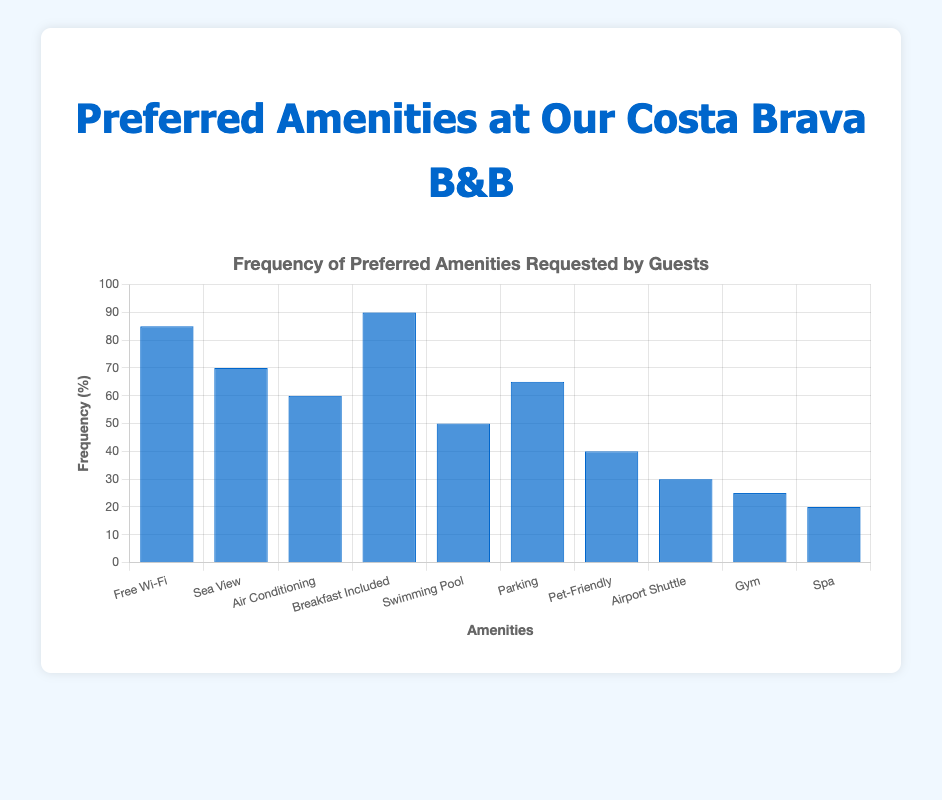What's the most frequently requested amenity? Look at the bar reaching the highest point. The blue bar for "Breakfast Included" is the highest, indicating it has the highest frequency.
Answer: Breakfast Included Which amenity is requested less frequently: "Spa" or "Gym"? Compare the bar heights of "Spa" and "Gym". The bar for "Spa" is shorter than the bar for "Gym".
Answer: Spa What is the combined frequency of "Sea View" and "Air Conditioning"? Find the frequencies of "Sea View" (70) and "Air Conditioning" (60). Add them together: 70 + 60 = 130.
Answer: 130 Is "Pet-Friendly" more requested than "Airport Shuttle"? Compare the heights of the "Pet-Friendly" and "Airport Shuttle" bars. The "Pet-Friendly" bar is taller than the "Airport Shuttle" bar.
Answer: Yes By how much does the frequency of "Parking" exceed "Gym"? Find the frequencies of "Parking" (65) and "Gym" (25). Subtract the frequency of "Gym" from "Parking": 65 - 25 = 40.
Answer: 40 Rank the top three amenities based on frequency. Identify the three tallest bars. The bars for "Breakfast Included," "Free Wi-Fi," and "Sea View" are the top three, in that order.
Answer: Breakfast Included, Free Wi-Fi, Sea View What is the average frequency of all the amenities listed? Sum the frequencies (85 + 70 + 60 + 90 + 50 + 65 + 40 + 30 + 25 + 20 = 535). Divide by the number of amenities (10): 535 / 10 = 53.5.
Answer: 53.5 Which amenities have a frequency between 50 and 70? Identify bars whose heights fall between 50 and 70. "Sea View" (70), "Air Conditioning" (60), and "Parking" (65) meet the criteria.
Answer: Sea View, Air Conditioning, Parking How much more frequently is "Free Wi-Fi" requested compared to "Swimming Pool"? Find the frequencies of "Free Wi-Fi" (85) and "Swimming Pool" (50). Subtract the frequency of "Swimming Pool" from "Free Wi-Fi": 85 - 50 = 35.
Answer: 35 Which amenity is the least requested? Look for the shortest bar. The shortest bar belongs to "Spa," indicating it is the least requested.
Answer: Spa 